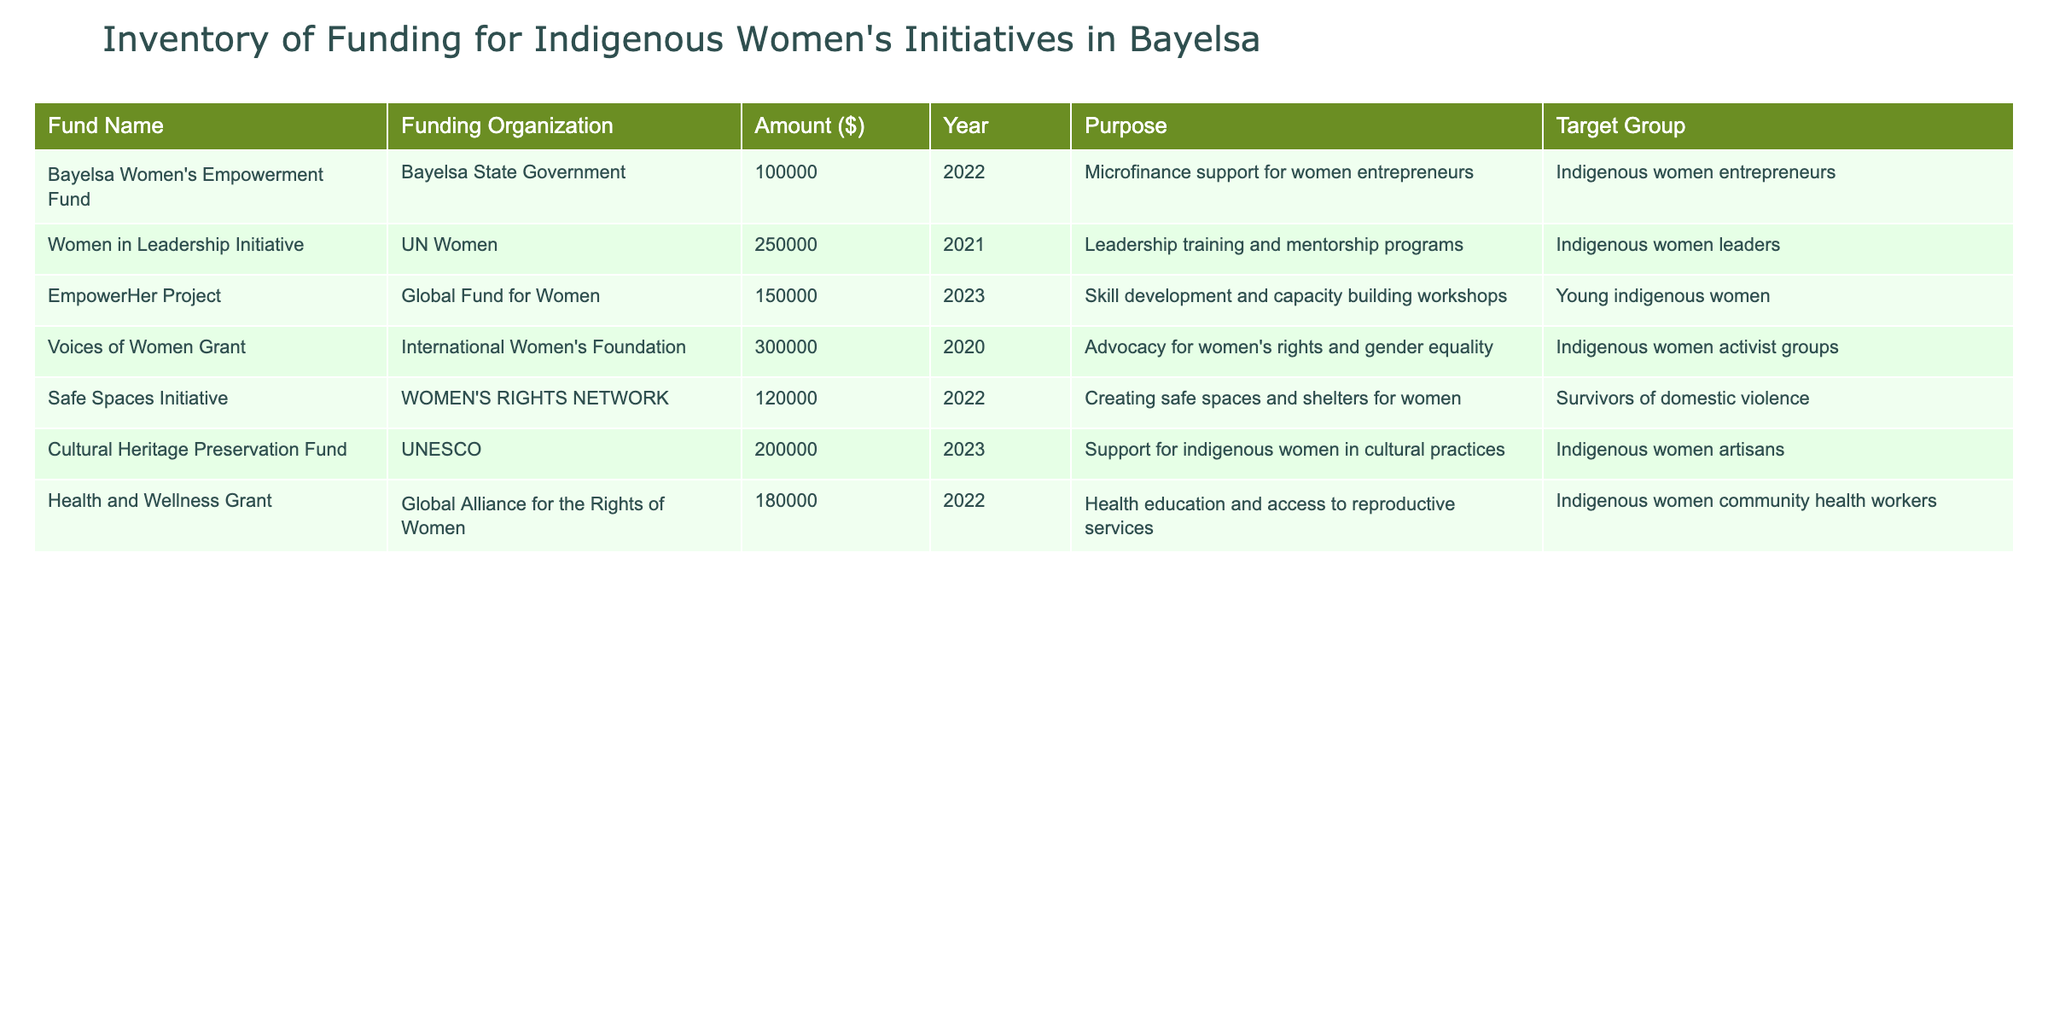What is the total amount of funding for the EmpowerHer Project? The table indicates that the amount for the EmpowerHer Project is 150000. This value can be retrieved directly from the table without any calculations or combinations.
Answer: 150000 Which year provided the highest funding amount? The table shows that the Women in Leadership Initiative received the highest funding amount of 250000 in the year 2021. This can be identified by comparing all the funding amounts listed in the table.
Answer: 2021 How many initiatives had a purpose related to skill development? The table includes two initiatives related to skill development: the Women in Leadership Initiative and the EmpowerHer Project. By reviewing the purpose field in each row, we can identify these two specific entries.
Answer: 2 What is the average funding amount across all initiatives listed? To calculate the average funding amount, sum all the amounts (100000 + 250000 + 150000 + 300000 + 120000 + 200000 + 180000) which equals 1300000. Then, divide by the number of initiatives (7), resulting in an average of 1300000/7 = 185714.29.
Answer: 185714 Was there any funding provided for health education? The table lists the Health and Wellness Grant with a purpose that explicitly states health education and access to reproductive services, confirming the existence of funding for this need.
Answer: Yes Which funding organization provided support for indigenous women artisans? The table specifies that the Cultural Heritage Preservation Fund, organized by UNESCO, supports indigenous women artisans, which can be found in the corresponding row of the table.
Answer: UNESCO How much total funding was aimed at indigenous women leaders? There are two initiatives aimed at indigenous women leaders: the Women in Leadership Initiative (250000) and the Voices of Women Grant (300000). Summing these amounts gives 250000 + 300000 = 550000.
Answer: 550000 Did the Safe Spaces Initiative receive more funding than the Bayelsa Women's Empowerment Fund? The Safe Spaces Initiative received 120000, while the Bayelsa Women's Empowerment Fund received 100000. Since 120000 is greater than 100000, we can conclude that the Safe Spaces Initiative did receive more funding.
Answer: Yes Which initiatives were launched in the year 2022? The initiatives launched in 2022 include the Bayelsa Women's Empowerment Fund (100000) and the Safe Spaces Initiative (120000). This is determined by filtering the table for the year 2022 and reviewing the corresponding rows.
Answer: 2 